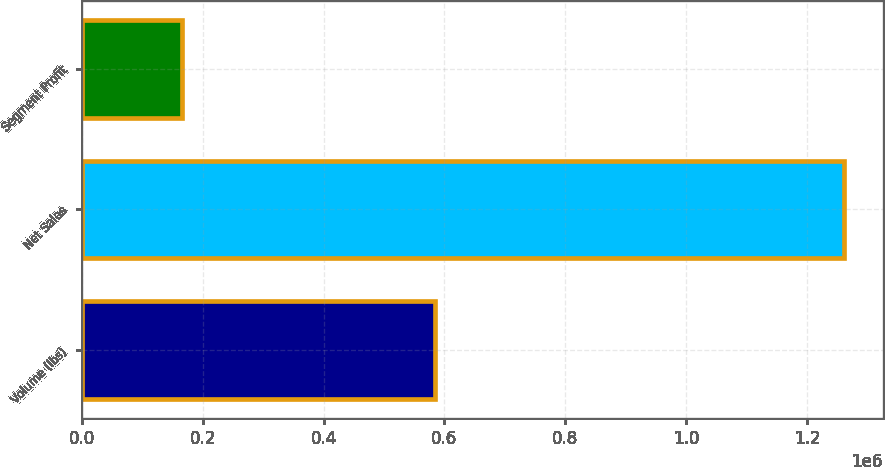<chart> <loc_0><loc_0><loc_500><loc_500><bar_chart><fcel>Volume (lbs)<fcel>Net Sales<fcel>Segment Profit<nl><fcel>583526<fcel>1.26205e+06<fcel>166253<nl></chart> 